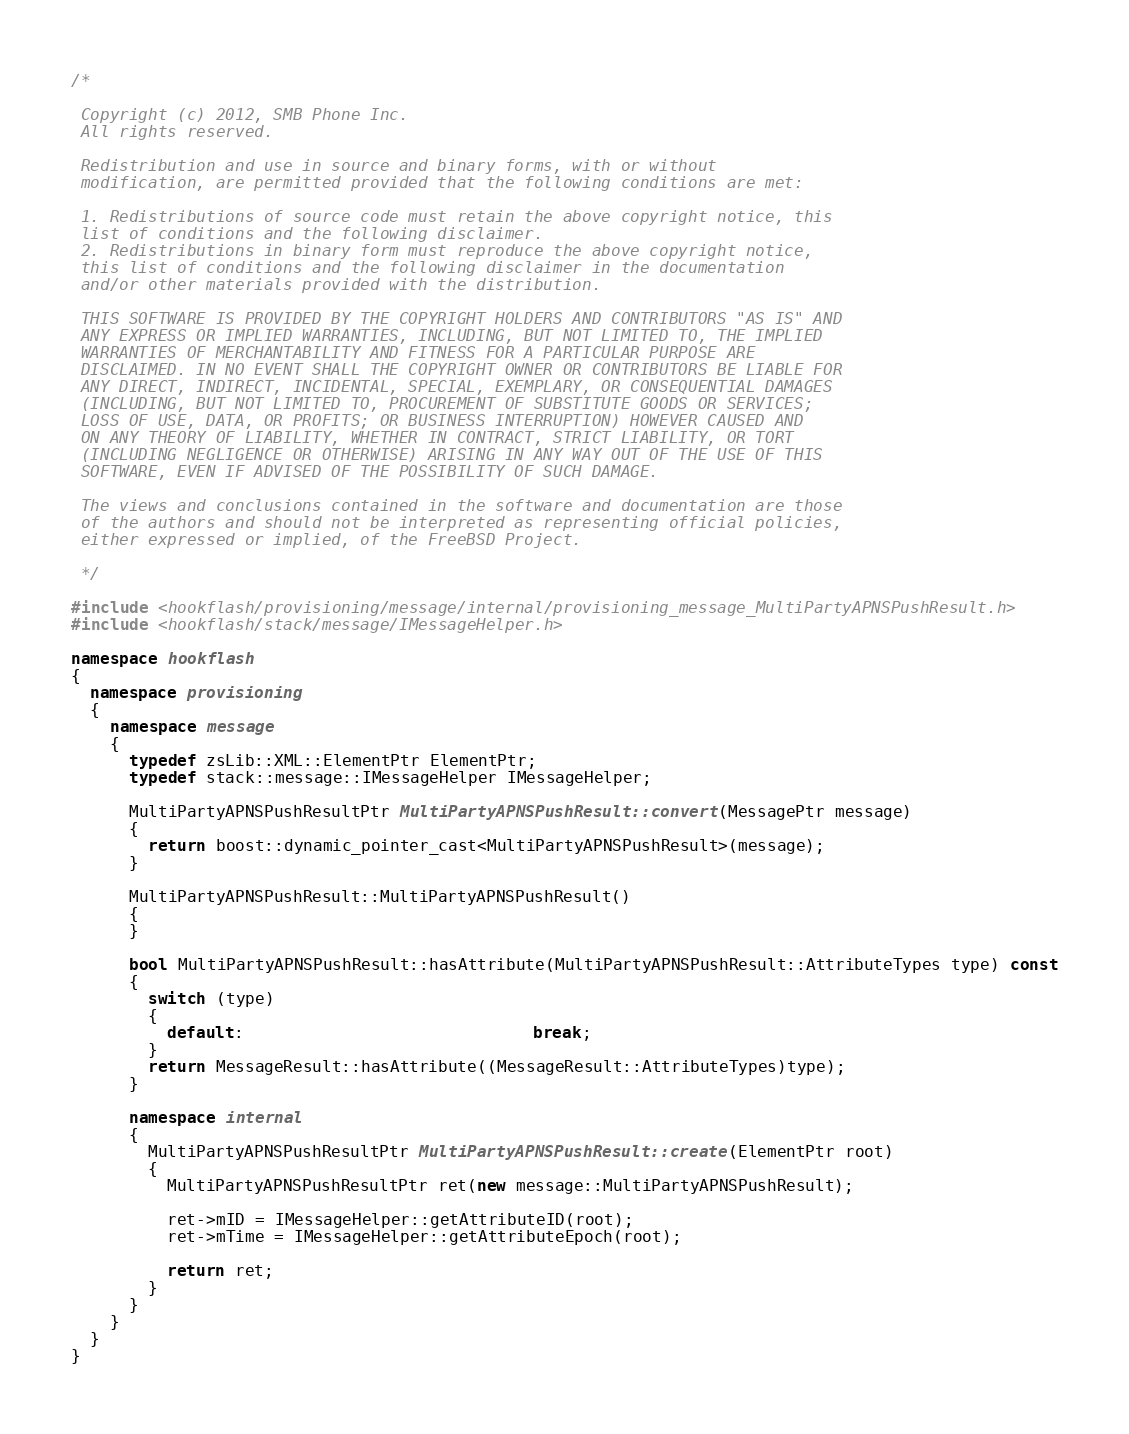<code> <loc_0><loc_0><loc_500><loc_500><_C++_>/*
 
 Copyright (c) 2012, SMB Phone Inc.
 All rights reserved.
 
 Redistribution and use in source and binary forms, with or without
 modification, are permitted provided that the following conditions are met:
 
 1. Redistributions of source code must retain the above copyright notice, this
 list of conditions and the following disclaimer.
 2. Redistributions in binary form must reproduce the above copyright notice,
 this list of conditions and the following disclaimer in the documentation
 and/or other materials provided with the distribution.
 
 THIS SOFTWARE IS PROVIDED BY THE COPYRIGHT HOLDERS AND CONTRIBUTORS "AS IS" AND
 ANY EXPRESS OR IMPLIED WARRANTIES, INCLUDING, BUT NOT LIMITED TO, THE IMPLIED
 WARRANTIES OF MERCHANTABILITY AND FITNESS FOR A PARTICULAR PURPOSE ARE
 DISCLAIMED. IN NO EVENT SHALL THE COPYRIGHT OWNER OR CONTRIBUTORS BE LIABLE FOR
 ANY DIRECT, INDIRECT, INCIDENTAL, SPECIAL, EXEMPLARY, OR CONSEQUENTIAL DAMAGES
 (INCLUDING, BUT NOT LIMITED TO, PROCUREMENT OF SUBSTITUTE GOODS OR SERVICES;
 LOSS OF USE, DATA, OR PROFITS; OR BUSINESS INTERRUPTION) HOWEVER CAUSED AND
 ON ANY THEORY OF LIABILITY, WHETHER IN CONTRACT, STRICT LIABILITY, OR TORT
 (INCLUDING NEGLIGENCE OR OTHERWISE) ARISING IN ANY WAY OUT OF THE USE OF THIS
 SOFTWARE, EVEN IF ADVISED OF THE POSSIBILITY OF SUCH DAMAGE.
 
 The views and conclusions contained in the software and documentation are those
 of the authors and should not be interpreted as representing official policies,
 either expressed or implied, of the FreeBSD Project.
 
 */

#include <hookflash/provisioning/message/internal/provisioning_message_MultiPartyAPNSPushResult.h>
#include <hookflash/stack/message/IMessageHelper.h>

namespace hookflash
{
  namespace provisioning
  {
    namespace message
    {
      typedef zsLib::XML::ElementPtr ElementPtr;
      typedef stack::message::IMessageHelper IMessageHelper;

      MultiPartyAPNSPushResultPtr MultiPartyAPNSPushResult::convert(MessagePtr message)
      {
        return boost::dynamic_pointer_cast<MultiPartyAPNSPushResult>(message);
      }

      MultiPartyAPNSPushResult::MultiPartyAPNSPushResult()
      {
      }

      bool MultiPartyAPNSPushResult::hasAttribute(MultiPartyAPNSPushResult::AttributeTypes type) const
      {
        switch (type)
        {
          default:                              break;
        }
        return MessageResult::hasAttribute((MessageResult::AttributeTypes)type);
      }

      namespace internal
      {
        MultiPartyAPNSPushResultPtr MultiPartyAPNSPushResult::create(ElementPtr root)
        {
          MultiPartyAPNSPushResultPtr ret(new message::MultiPartyAPNSPushResult);

          ret->mID = IMessageHelper::getAttributeID(root);
          ret->mTime = IMessageHelper::getAttributeEpoch(root);

          return ret;
        }
      }
    }
  }
}
</code> 